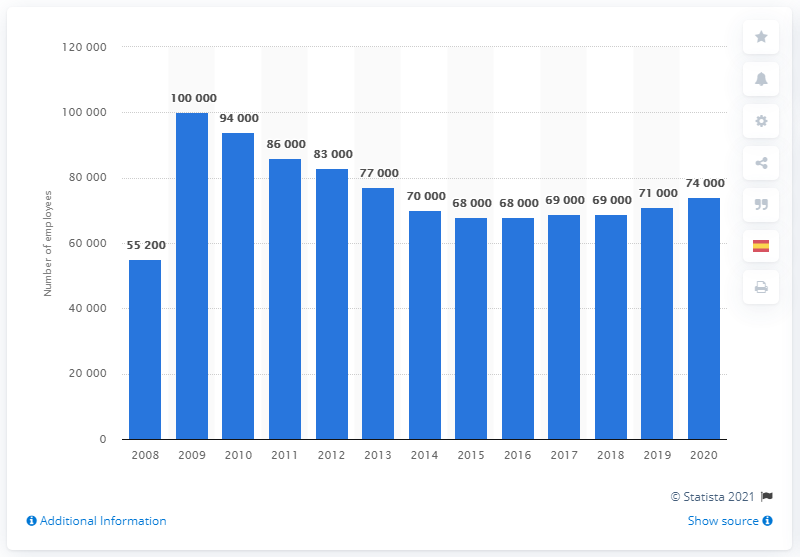In what year did Merck & Co. have the largest number of employees? According to the bar chart, Merck & Co. had the largest number of employees in 2009, with a workforce totaling 100,000 individuals. This number is depicted as the highest bar on the chart, indicating the peak of their employment over the observed period from 2008 to 2020. 